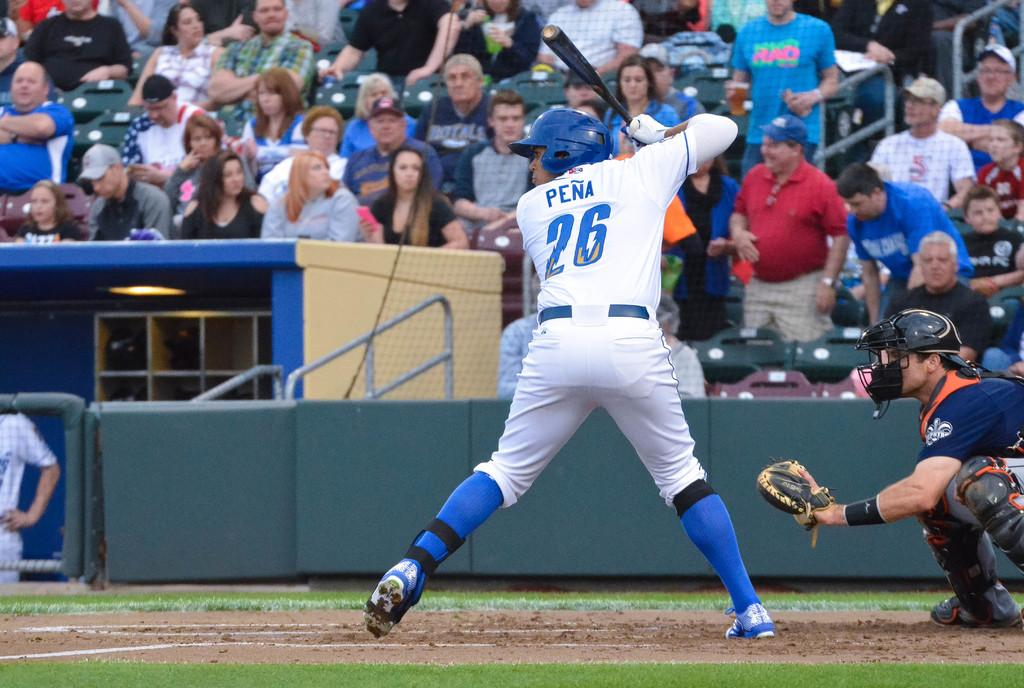<image>
Offer a succinct explanation of the picture presented. A baseball player named Pena is preparing to bat 